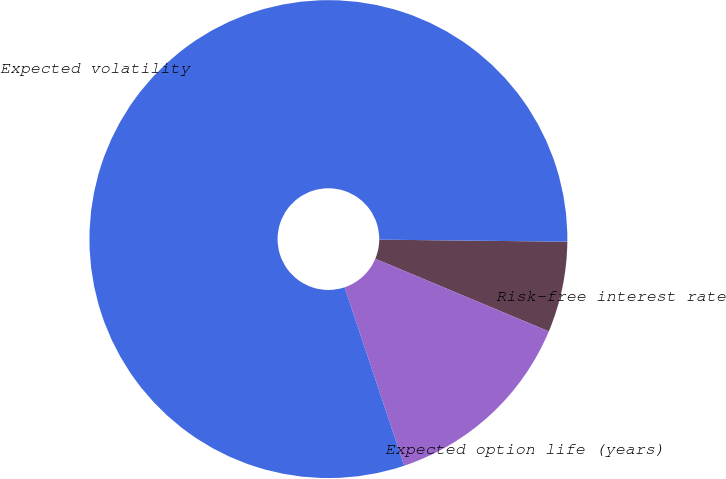<chart> <loc_0><loc_0><loc_500><loc_500><pie_chart><fcel>Risk-free interest rate<fcel>Expected option life (years)<fcel>Expected volatility<nl><fcel>6.14%<fcel>13.55%<fcel>80.31%<nl></chart> 